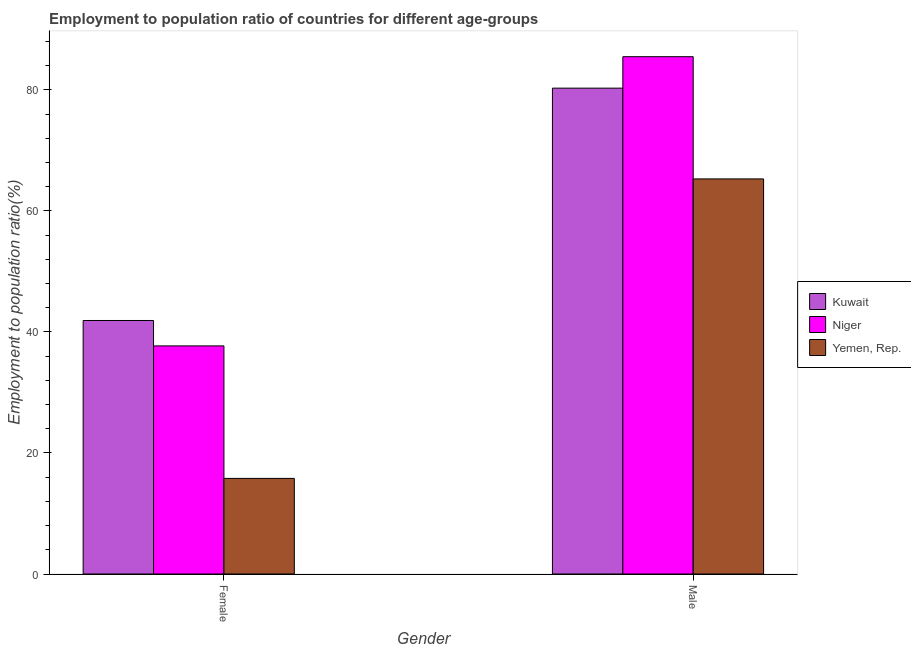How many different coloured bars are there?
Provide a short and direct response. 3. How many bars are there on the 1st tick from the left?
Give a very brief answer. 3. How many bars are there on the 1st tick from the right?
Offer a terse response. 3. What is the label of the 1st group of bars from the left?
Your answer should be compact. Female. What is the employment to population ratio(female) in Kuwait?
Your response must be concise. 41.9. Across all countries, what is the maximum employment to population ratio(female)?
Ensure brevity in your answer.  41.9. Across all countries, what is the minimum employment to population ratio(male)?
Your response must be concise. 65.3. In which country was the employment to population ratio(male) maximum?
Your answer should be compact. Niger. In which country was the employment to population ratio(female) minimum?
Provide a short and direct response. Yemen, Rep. What is the total employment to population ratio(male) in the graph?
Your answer should be compact. 231.1. What is the difference between the employment to population ratio(male) in Yemen, Rep. and that in Niger?
Give a very brief answer. -20.2. What is the difference between the employment to population ratio(male) in Kuwait and the employment to population ratio(female) in Yemen, Rep.?
Your answer should be compact. 64.5. What is the average employment to population ratio(male) per country?
Offer a terse response. 77.03. What is the difference between the employment to population ratio(female) and employment to population ratio(male) in Yemen, Rep.?
Offer a terse response. -49.5. What is the ratio of the employment to population ratio(male) in Niger to that in Kuwait?
Your answer should be compact. 1.06. What does the 2nd bar from the left in Female represents?
Your response must be concise. Niger. What does the 2nd bar from the right in Female represents?
Your answer should be very brief. Niger. Are all the bars in the graph horizontal?
Your answer should be very brief. No. Does the graph contain any zero values?
Ensure brevity in your answer.  No. Does the graph contain grids?
Your answer should be compact. No. Where does the legend appear in the graph?
Provide a short and direct response. Center right. How are the legend labels stacked?
Your response must be concise. Vertical. What is the title of the graph?
Keep it short and to the point. Employment to population ratio of countries for different age-groups. Does "Russian Federation" appear as one of the legend labels in the graph?
Your answer should be compact. No. What is the label or title of the X-axis?
Your response must be concise. Gender. What is the Employment to population ratio(%) in Kuwait in Female?
Provide a short and direct response. 41.9. What is the Employment to population ratio(%) of Niger in Female?
Offer a very short reply. 37.7. What is the Employment to population ratio(%) in Yemen, Rep. in Female?
Give a very brief answer. 15.8. What is the Employment to population ratio(%) of Kuwait in Male?
Offer a very short reply. 80.3. What is the Employment to population ratio(%) of Niger in Male?
Offer a very short reply. 85.5. What is the Employment to population ratio(%) in Yemen, Rep. in Male?
Offer a terse response. 65.3. Across all Gender, what is the maximum Employment to population ratio(%) in Kuwait?
Make the answer very short. 80.3. Across all Gender, what is the maximum Employment to population ratio(%) of Niger?
Give a very brief answer. 85.5. Across all Gender, what is the maximum Employment to population ratio(%) of Yemen, Rep.?
Provide a short and direct response. 65.3. Across all Gender, what is the minimum Employment to population ratio(%) of Kuwait?
Provide a short and direct response. 41.9. Across all Gender, what is the minimum Employment to population ratio(%) in Niger?
Your answer should be very brief. 37.7. Across all Gender, what is the minimum Employment to population ratio(%) in Yemen, Rep.?
Your response must be concise. 15.8. What is the total Employment to population ratio(%) of Kuwait in the graph?
Your answer should be very brief. 122.2. What is the total Employment to population ratio(%) of Niger in the graph?
Ensure brevity in your answer.  123.2. What is the total Employment to population ratio(%) in Yemen, Rep. in the graph?
Ensure brevity in your answer.  81.1. What is the difference between the Employment to population ratio(%) in Kuwait in Female and that in Male?
Give a very brief answer. -38.4. What is the difference between the Employment to population ratio(%) of Niger in Female and that in Male?
Offer a terse response. -47.8. What is the difference between the Employment to population ratio(%) of Yemen, Rep. in Female and that in Male?
Provide a short and direct response. -49.5. What is the difference between the Employment to population ratio(%) of Kuwait in Female and the Employment to population ratio(%) of Niger in Male?
Offer a terse response. -43.6. What is the difference between the Employment to population ratio(%) in Kuwait in Female and the Employment to population ratio(%) in Yemen, Rep. in Male?
Make the answer very short. -23.4. What is the difference between the Employment to population ratio(%) of Niger in Female and the Employment to population ratio(%) of Yemen, Rep. in Male?
Provide a short and direct response. -27.6. What is the average Employment to population ratio(%) of Kuwait per Gender?
Ensure brevity in your answer.  61.1. What is the average Employment to population ratio(%) of Niger per Gender?
Offer a terse response. 61.6. What is the average Employment to population ratio(%) of Yemen, Rep. per Gender?
Ensure brevity in your answer.  40.55. What is the difference between the Employment to population ratio(%) in Kuwait and Employment to population ratio(%) in Niger in Female?
Provide a short and direct response. 4.2. What is the difference between the Employment to population ratio(%) in Kuwait and Employment to population ratio(%) in Yemen, Rep. in Female?
Ensure brevity in your answer.  26.1. What is the difference between the Employment to population ratio(%) in Niger and Employment to population ratio(%) in Yemen, Rep. in Female?
Make the answer very short. 21.9. What is the difference between the Employment to population ratio(%) of Niger and Employment to population ratio(%) of Yemen, Rep. in Male?
Give a very brief answer. 20.2. What is the ratio of the Employment to population ratio(%) of Kuwait in Female to that in Male?
Offer a terse response. 0.52. What is the ratio of the Employment to population ratio(%) in Niger in Female to that in Male?
Give a very brief answer. 0.44. What is the ratio of the Employment to population ratio(%) of Yemen, Rep. in Female to that in Male?
Offer a very short reply. 0.24. What is the difference between the highest and the second highest Employment to population ratio(%) in Kuwait?
Provide a succinct answer. 38.4. What is the difference between the highest and the second highest Employment to population ratio(%) in Niger?
Make the answer very short. 47.8. What is the difference between the highest and the second highest Employment to population ratio(%) of Yemen, Rep.?
Your answer should be very brief. 49.5. What is the difference between the highest and the lowest Employment to population ratio(%) of Kuwait?
Your answer should be very brief. 38.4. What is the difference between the highest and the lowest Employment to population ratio(%) of Niger?
Offer a terse response. 47.8. What is the difference between the highest and the lowest Employment to population ratio(%) in Yemen, Rep.?
Provide a succinct answer. 49.5. 